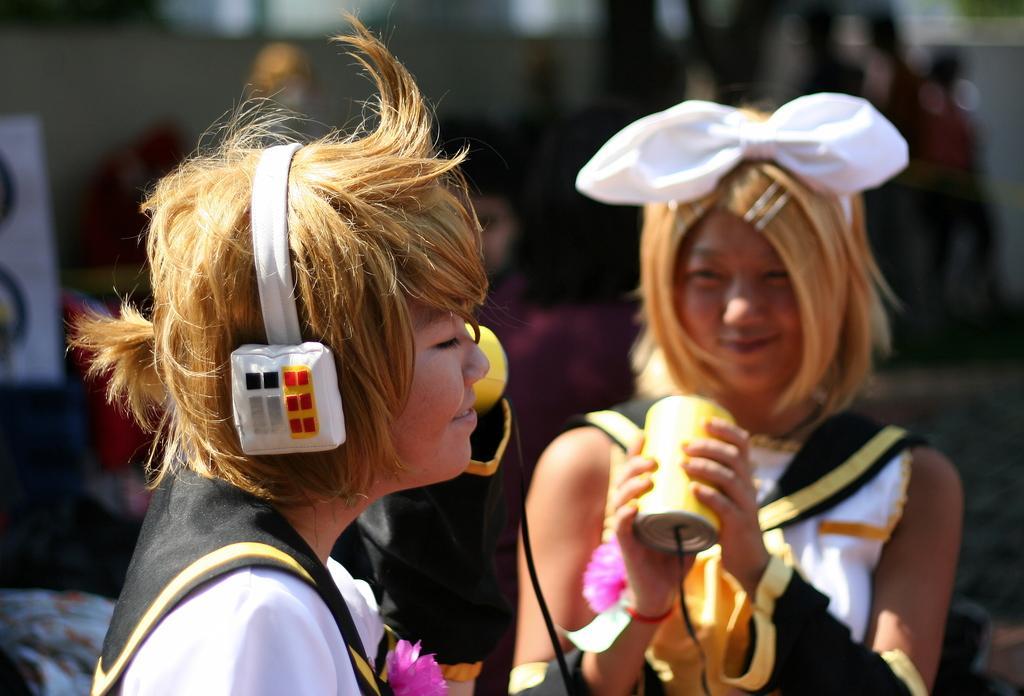In one or two sentences, can you explain what this image depicts? In this image we can see two persons wearing similar dress, a person put her headphones which is connected with a wire to the box which is held by the other person standing in the background and the background image is blur. 